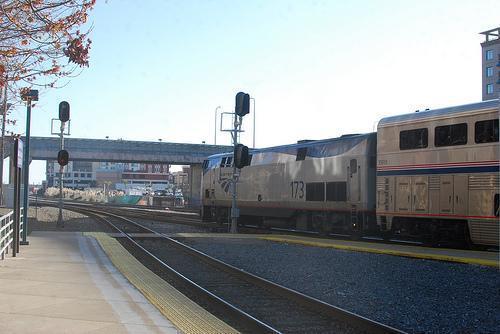How many lights do you see?
Give a very brief answer. 2. How many tracks are occupied?
Give a very brief answer. 1. 